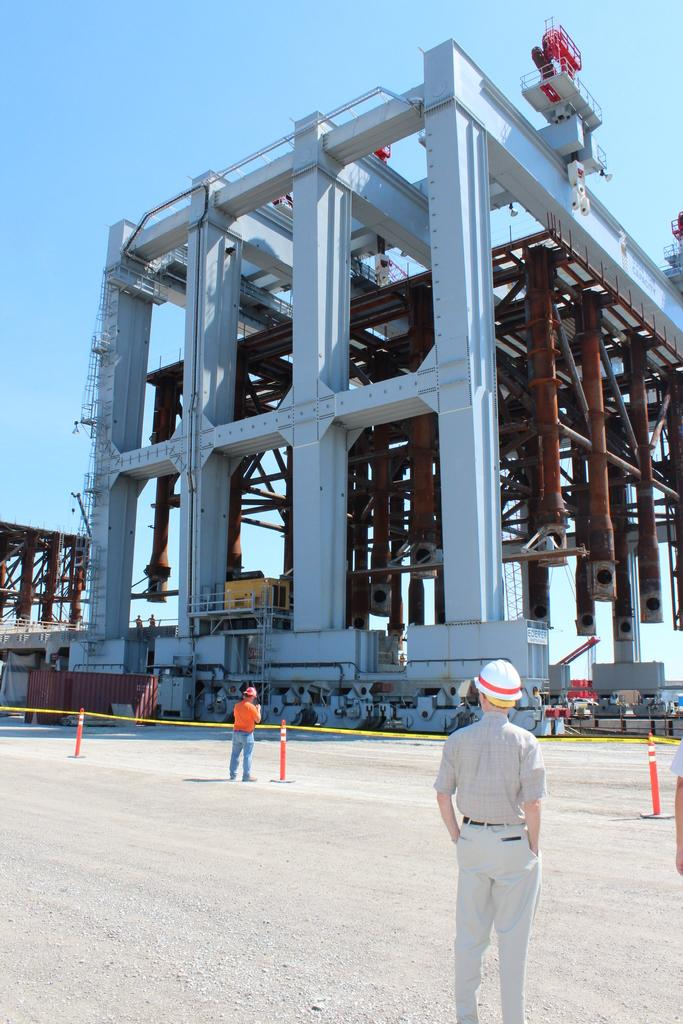Who or what is present at the bottom of the image? There are persons in the image, and they are located at the bottom. What can be seen above the persons in the image? There is sky visible at the top of the image. What is happening in the middle of the image? Construction is taking place in the middle of the image. How many apples are being used as construction materials in the image? There are no apples present in the image, and they are not being used as construction materials. 